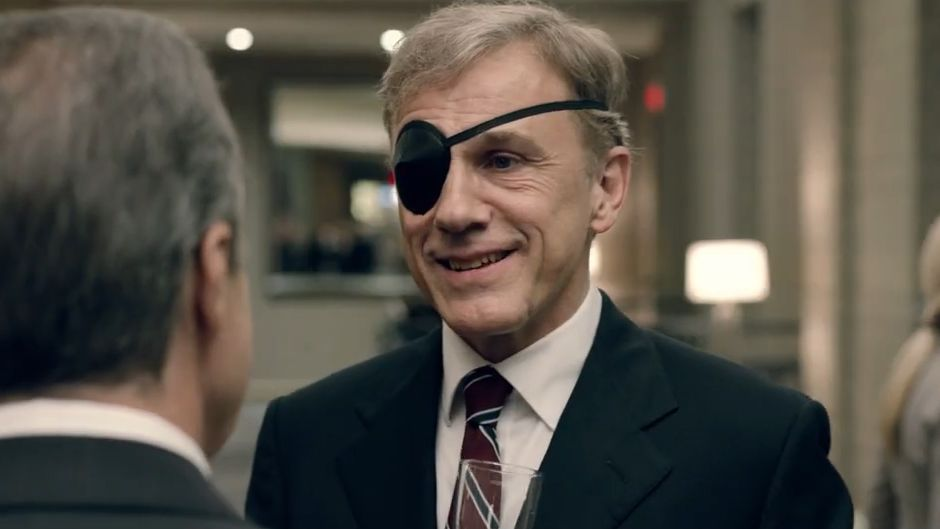In a very creative scenario, what if the character Christoph Waltz is portraying is a renowned pirate who transformed his career? Imagine Christoph Waltz's character as Captain Viktor Blackstone, a notorious pirate who ruled the high seas with an iron fist. After decades of plundering and swashbuckling adventures, he decides to turn over a new leaf and channel his strategic brilliance into the corporate world. The eye patch, once a symbol of his fierce maritime exploits, now serves as a reminder of his tumultuous past. In this moment, he is at a lavish corporate party, having rebranded himself as a savvy, unorthodox business consultant known for his unshakeable resolve and cunning tactics. His reputation commands both respect and fear, and tonight he’s closing a deal that involves a bold takeover of a tech company. The unsuspecting attendees are mesmerized by his tales of adventure, unaware of the pirate legacy that steers his every move. This blend of nautical history with sharp corporate maneuvering paints a thrilling and imaginative picture of a man who has truly lived multiple lifetimes. 